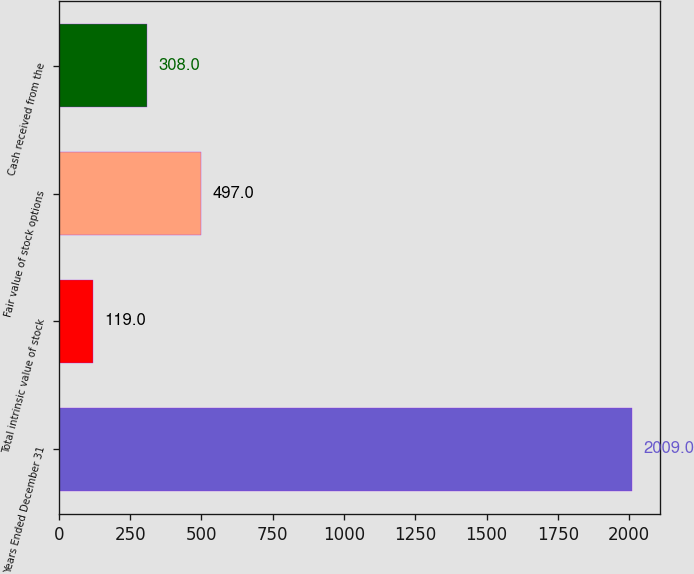<chart> <loc_0><loc_0><loc_500><loc_500><bar_chart><fcel>Years Ended December 31<fcel>Total intrinsic value of stock<fcel>Fair value of stock options<fcel>Cash received from the<nl><fcel>2009<fcel>119<fcel>497<fcel>308<nl></chart> 